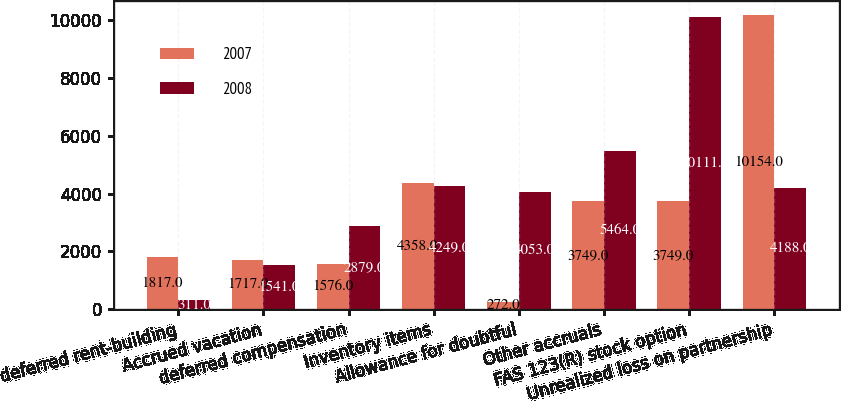Convert chart to OTSL. <chart><loc_0><loc_0><loc_500><loc_500><stacked_bar_chart><ecel><fcel>deferred rent-building<fcel>Accrued vacation<fcel>deferred compensation<fcel>Inventory items<fcel>Allowance for doubtful<fcel>Other accruals<fcel>FAS 123(R) stock option<fcel>Unrealized loss on partnership<nl><fcel>2007<fcel>1817<fcel>1717<fcel>1576<fcel>4358<fcel>272<fcel>3749<fcel>3749<fcel>10154<nl><fcel>2008<fcel>311<fcel>1541<fcel>2879<fcel>4249<fcel>4053<fcel>5464<fcel>10111<fcel>4188<nl></chart> 